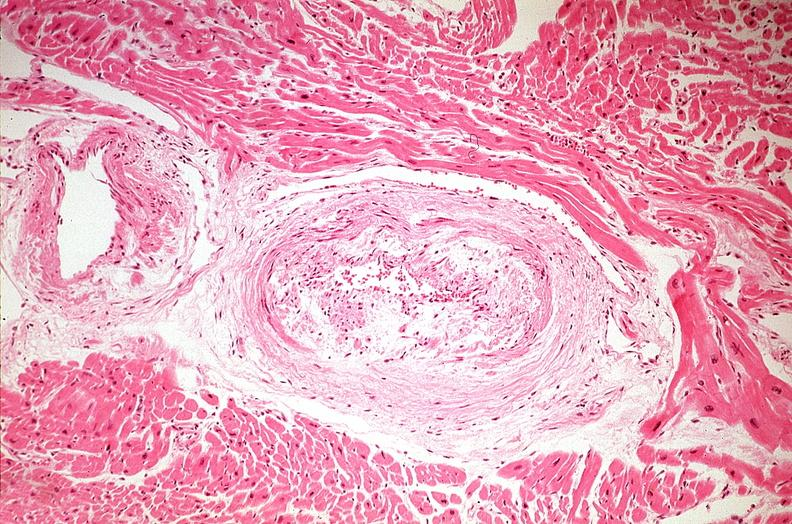does lesion show heart, myocardial infarction, wavey fiber change, necrtosis, hemorrhage, and dissection?
Answer the question using a single word or phrase. No 